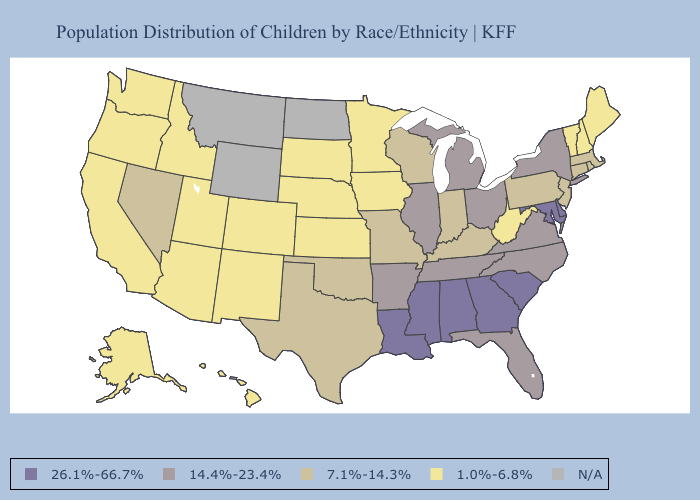Name the states that have a value in the range 14.4%-23.4%?
Write a very short answer. Arkansas, Florida, Illinois, Michigan, New York, North Carolina, Ohio, Tennessee, Virginia. Which states have the lowest value in the South?
Be succinct. West Virginia. Which states hav the highest value in the MidWest?
Short answer required. Illinois, Michigan, Ohio. Does New York have the lowest value in the Northeast?
Answer briefly. No. Which states have the lowest value in the Northeast?
Write a very short answer. Maine, New Hampshire, Vermont. What is the lowest value in the South?
Keep it brief. 1.0%-6.8%. What is the value of Iowa?
Answer briefly. 1.0%-6.8%. What is the value of Oklahoma?
Short answer required. 7.1%-14.3%. What is the value of Alaska?
Keep it brief. 1.0%-6.8%. What is the lowest value in states that border Florida?
Concise answer only. 26.1%-66.7%. Name the states that have a value in the range 14.4%-23.4%?
Short answer required. Arkansas, Florida, Illinois, Michigan, New York, North Carolina, Ohio, Tennessee, Virginia. What is the highest value in states that border Illinois?
Be succinct. 7.1%-14.3%. Does the map have missing data?
Concise answer only. Yes. 